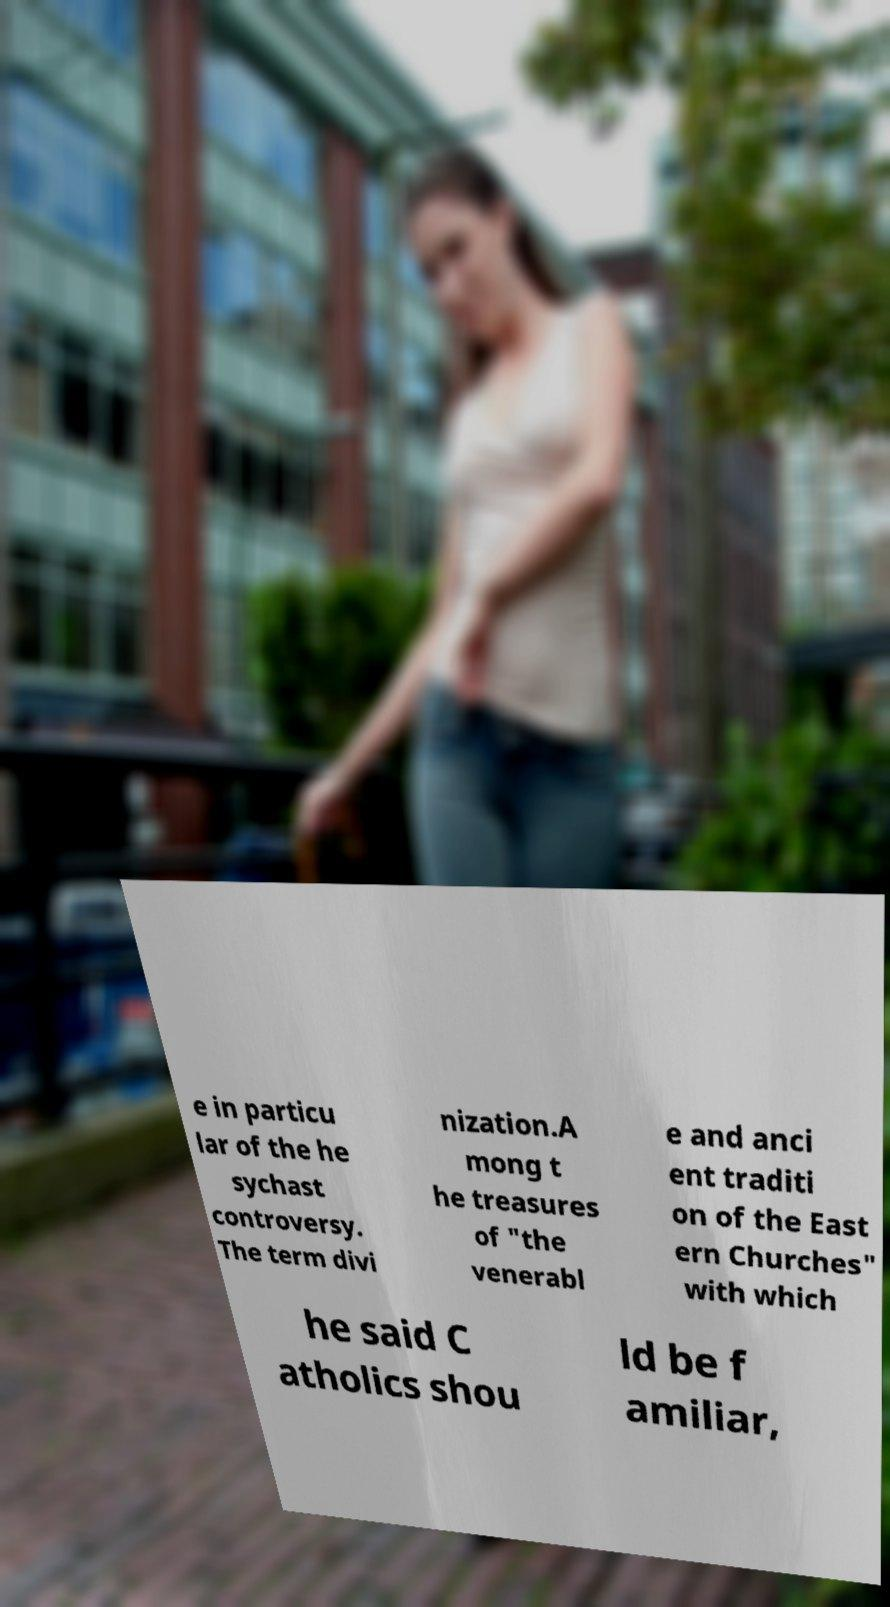Please read and relay the text visible in this image. What does it say? e in particu lar of the he sychast controversy. The term divi nization.A mong t he treasures of "the venerabl e and anci ent traditi on of the East ern Churches" with which he said C atholics shou ld be f amiliar, 